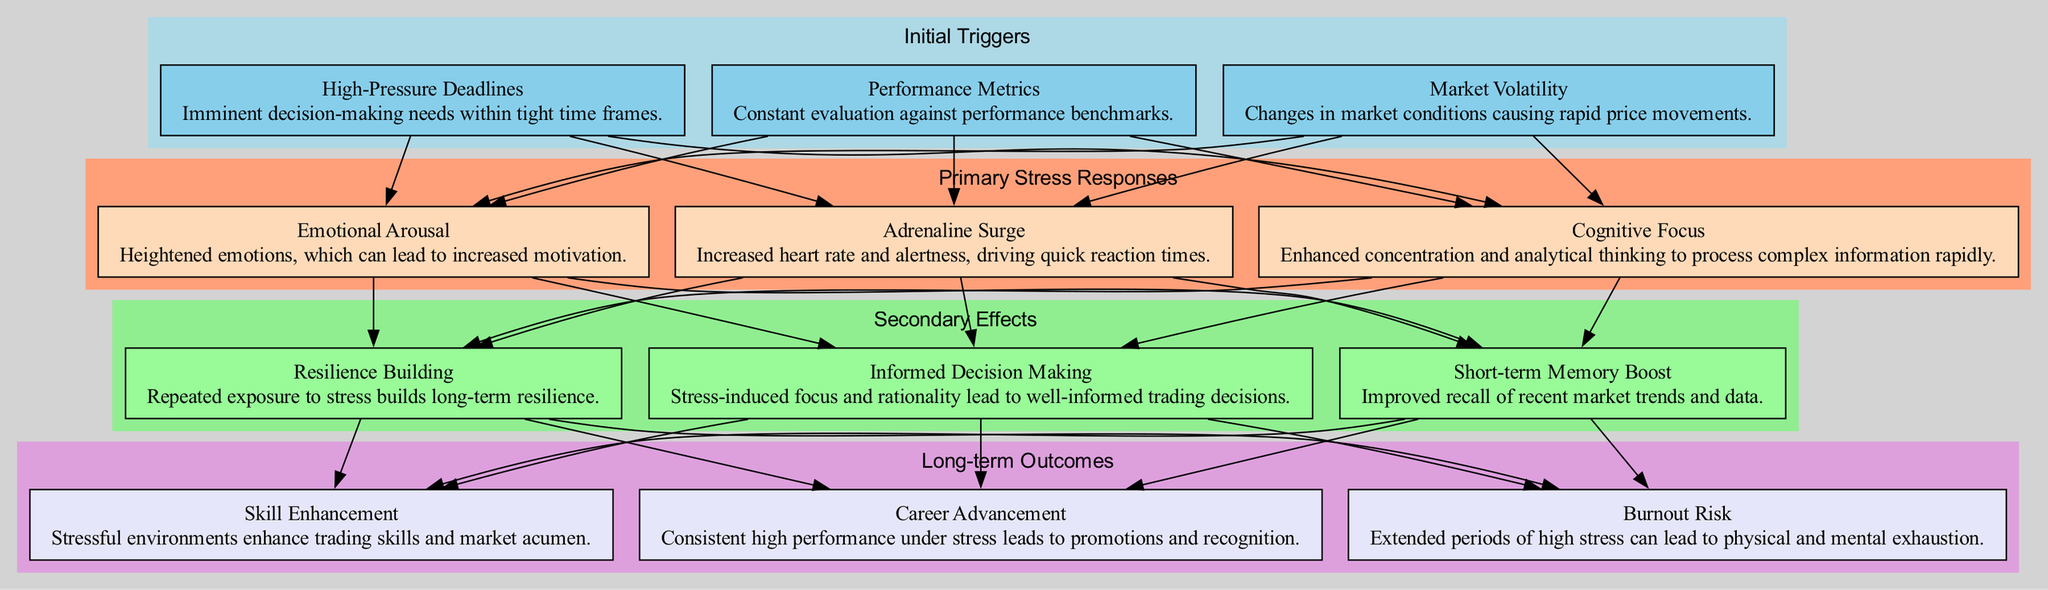What are the three initial triggers listed in the diagram? The diagram indicates three primary initial triggers that lead to stress responses: Market Volatility, High-Pressure Deadlines, and Performance Metrics. These triggers are specifically detailed within the 'Initial Triggers' cluster.
Answer: Market Volatility, High-Pressure Deadlines, Performance Metrics Which primary stress response is characterized by increased heart rate? According to the diagram, the response that is associated with increased heart rate is the Adrenaline Surge. This is specifically mentioned in the 'Primary Stress Responses' section.
Answer: Adrenaline Surge How many secondary effects are there in the diagram? By reviewing the 'Secondary Effects' section of the diagram, it shows that there are three listed effects: Informed Decision Making, Short-term Memory Boost, and Resilience Building. Hence, the total count is three.
Answer: 3 What is the connection between Cognitive Focus and Informed Decision Making? The diagram shows a directed edge from Cognitive Focus to Informed Decision Making, indicating that an enhanced concentration and analytical thinking contribute to making well-informed trading decisions. Therefore, they are directly linked in the pathway.
Answer: Cognitive Focus → Informed Decision Making Which long-term outcome relates to physical and mental exhaustion? The diagram specifies that Burnout Risk is the long-term outcome associated with extended periods of high stress. This outcome is found within the 'Long-term Outcomes' section of the diagram.
Answer: Burnout Risk Which initial trigger leads to Emotional Arousal as a primary stress response? Upon examining the diagram, it indicates that all three initial triggers (Market Volatility, High-Pressure Deadlines, Performance Metrics) connect to multiple primary stress responses including Emotional Arousal. Thus, any of the initial triggers could potentially lead to Emotional Arousal.
Answer: Market Volatility, High-Pressure Deadlines, Performance Metrics What is the final step in the stress response pathway? The last stage, or final step as shown in the diagram, is the Long-term Outcomes cluster, specifically noting outcomes like Career Advancement, Burnout Risk, and Skill Enhancement. This clearly outlines the terminal points of the stress response pathway.
Answer: Long-term Outcomes How does Stress contribute to Skill Enhancement in the long-term outcomes? The diagram illustrates that the Secondary Effects lead to Skill Enhancement. Stress-induced focus and resilience enable individuals to enhance their trading skills and market acumen over time, forming a logical flow from secondary effects to the final outcome of skill enhancement.
Answer: Stress enhances trading skills and market acumen 